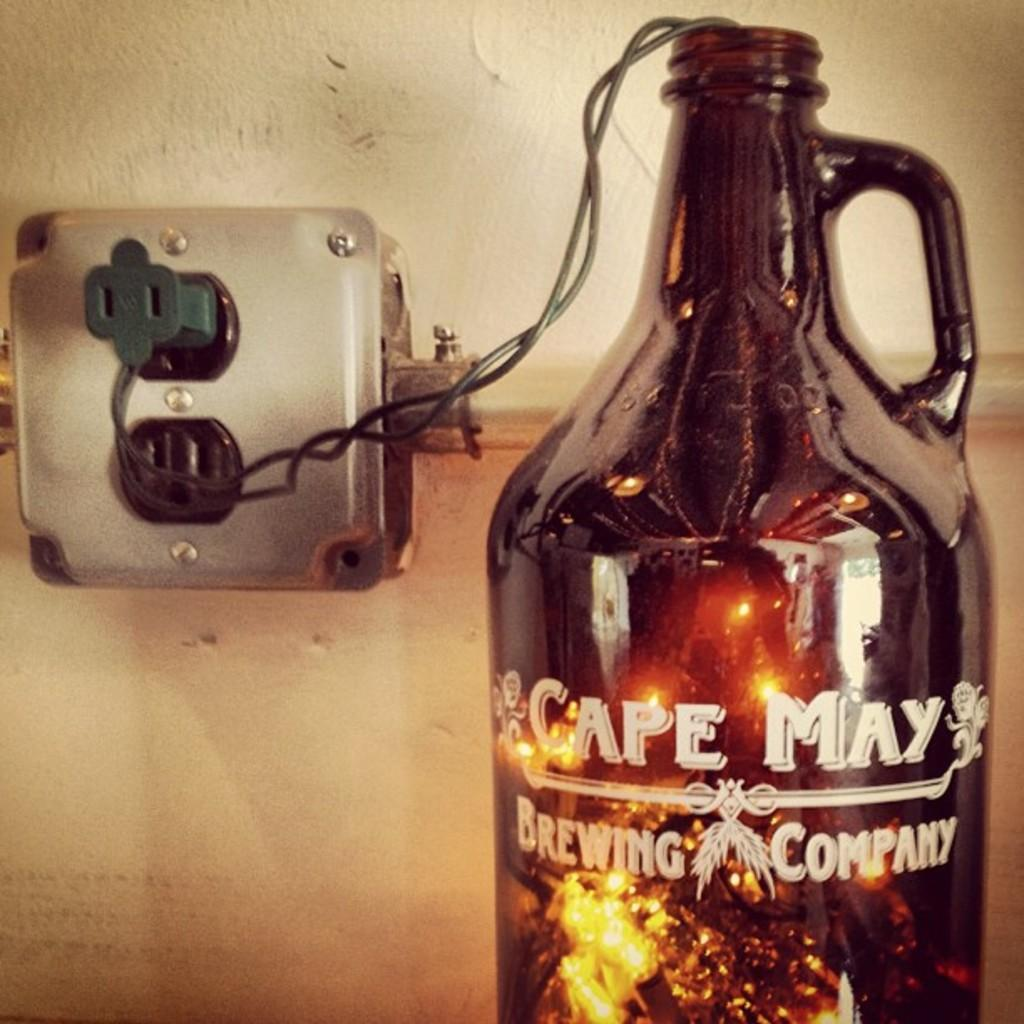What object is present in the image that contains liquid? There is a bottle in the image that contains liquid. What is unique about the liquid inside the bottle? The liquid inside the bottle has lights in it. Is there any text on the bottle? Yes, there is text on the bottle. What can be seen on the wall in the image? There is a socket board on the wall. How does the bottle affect the drain in the image? There is no drain present in the image, so it cannot be affected by the bottle. 